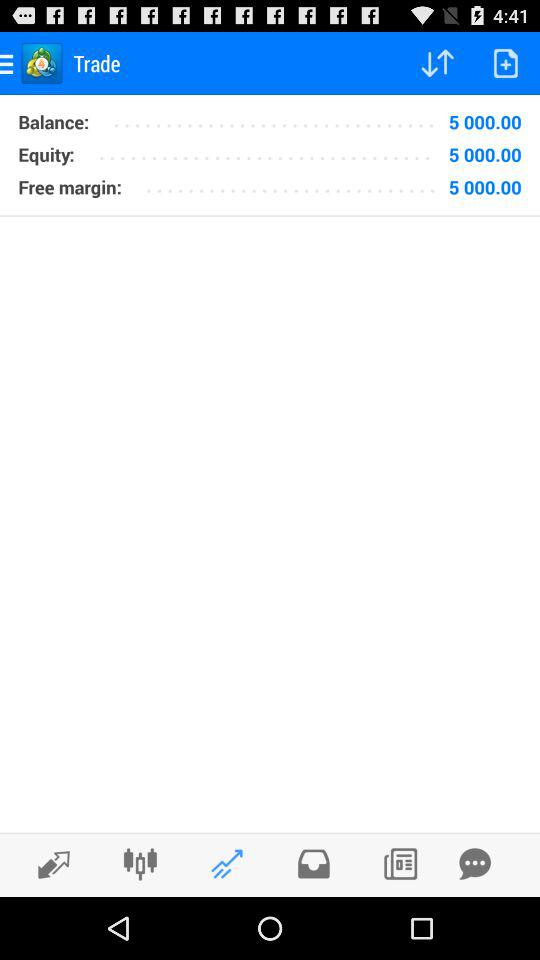What is the balance amount? The balance amount is 5000. 